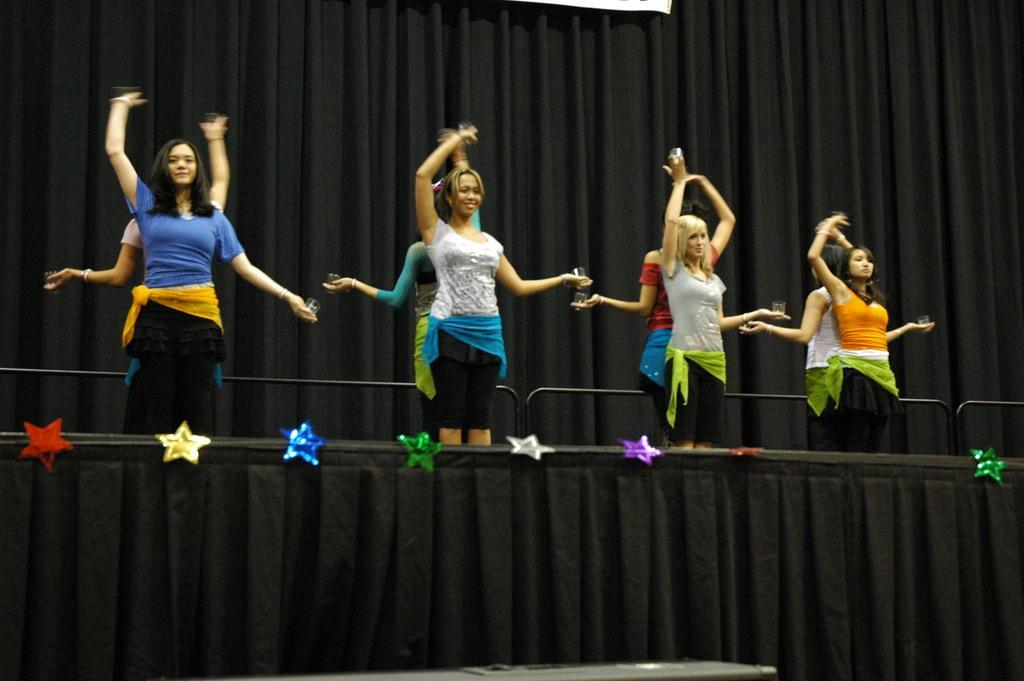Could you give a brief overview of what you see in this image? In the picture we can see some women are dancing on the stage and the stage is decorated with stars and behind the women we can see black color curtain. 